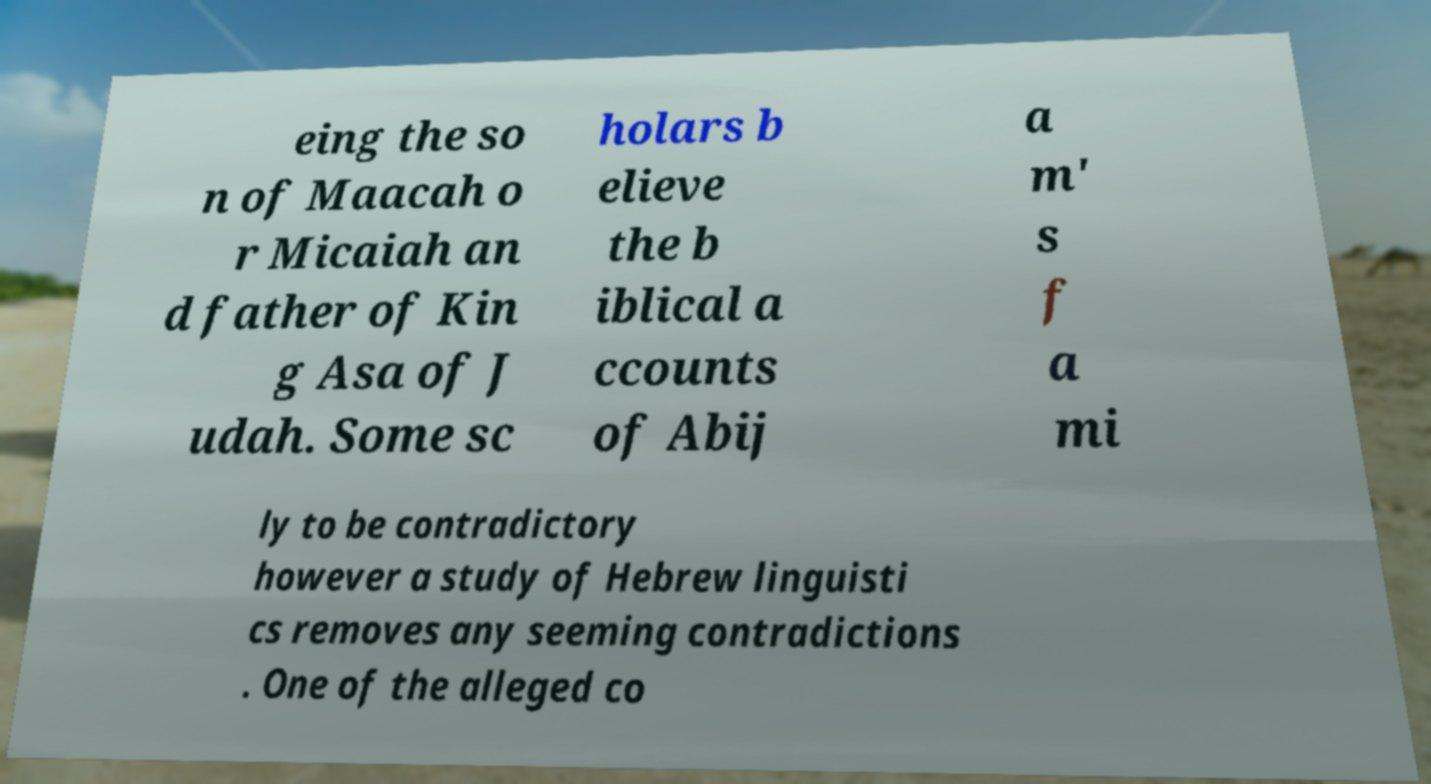Please read and relay the text visible in this image. What does it say? eing the so n of Maacah o r Micaiah an d father of Kin g Asa of J udah. Some sc holars b elieve the b iblical a ccounts of Abij a m' s f a mi ly to be contradictory however a study of Hebrew linguisti cs removes any seeming contradictions . One of the alleged co 